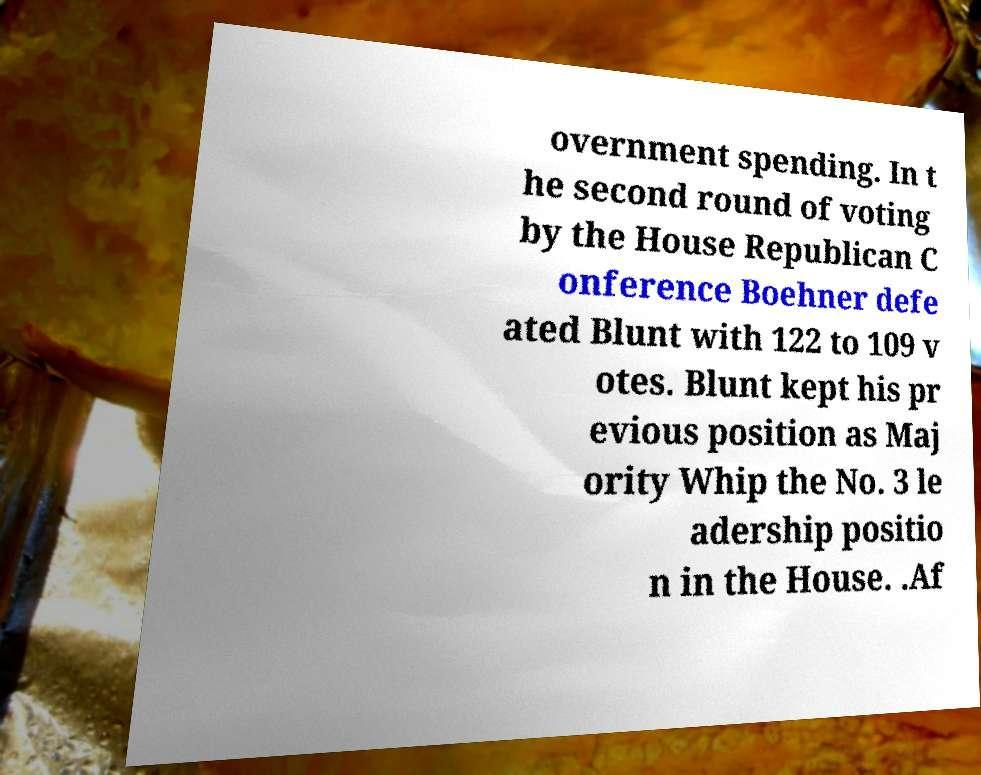Please identify and transcribe the text found in this image. overnment spending. In t he second round of voting by the House Republican C onference Boehner defe ated Blunt with 122 to 109 v otes. Blunt kept his pr evious position as Maj ority Whip the No. 3 le adership positio n in the House. .Af 